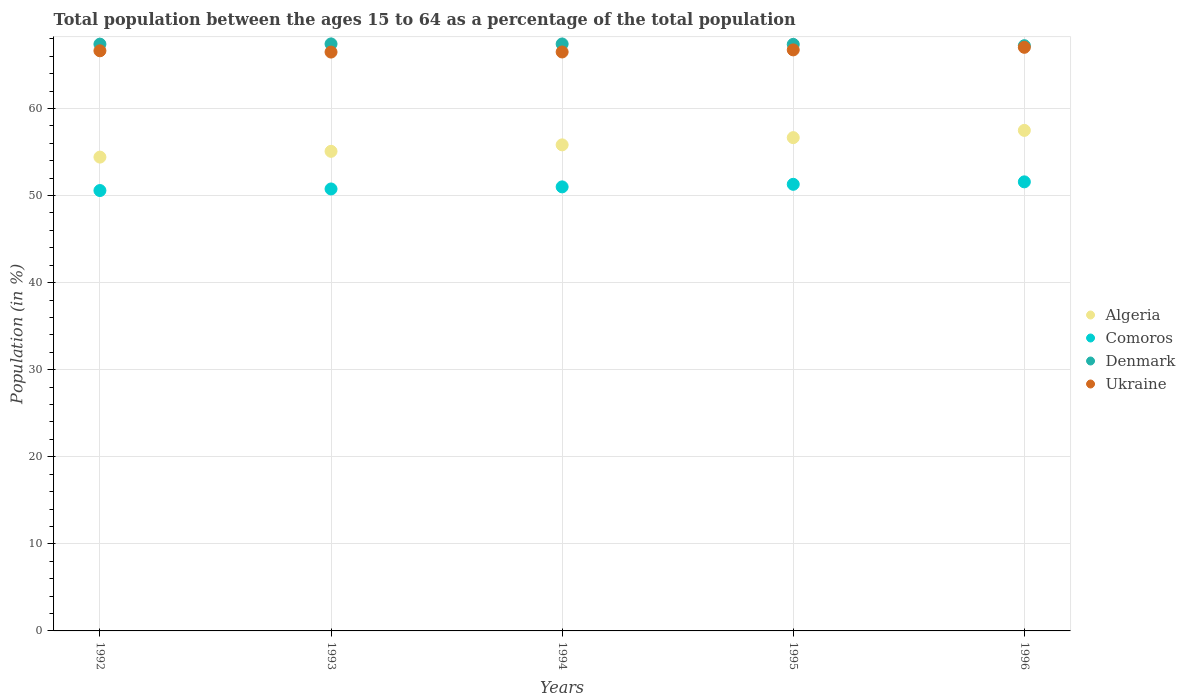How many different coloured dotlines are there?
Keep it short and to the point. 4. What is the percentage of the population ages 15 to 64 in Algeria in 1996?
Provide a succinct answer. 57.48. Across all years, what is the maximum percentage of the population ages 15 to 64 in Denmark?
Make the answer very short. 67.42. Across all years, what is the minimum percentage of the population ages 15 to 64 in Algeria?
Provide a short and direct response. 54.42. In which year was the percentage of the population ages 15 to 64 in Comoros minimum?
Offer a very short reply. 1992. What is the total percentage of the population ages 15 to 64 in Denmark in the graph?
Keep it short and to the point. 336.79. What is the difference between the percentage of the population ages 15 to 64 in Ukraine in 1992 and that in 1996?
Offer a terse response. -0.4. What is the difference between the percentage of the population ages 15 to 64 in Ukraine in 1993 and the percentage of the population ages 15 to 64 in Comoros in 1996?
Offer a terse response. 14.9. What is the average percentage of the population ages 15 to 64 in Denmark per year?
Make the answer very short. 67.36. In the year 1994, what is the difference between the percentage of the population ages 15 to 64 in Denmark and percentage of the population ages 15 to 64 in Ukraine?
Provide a short and direct response. 0.92. In how many years, is the percentage of the population ages 15 to 64 in Denmark greater than 30?
Make the answer very short. 5. What is the ratio of the percentage of the population ages 15 to 64 in Comoros in 1992 to that in 1993?
Keep it short and to the point. 1. Is the percentage of the population ages 15 to 64 in Algeria in 1992 less than that in 1993?
Give a very brief answer. Yes. Is the difference between the percentage of the population ages 15 to 64 in Denmark in 1994 and 1996 greater than the difference between the percentage of the population ages 15 to 64 in Ukraine in 1994 and 1996?
Make the answer very short. Yes. What is the difference between the highest and the second highest percentage of the population ages 15 to 64 in Comoros?
Provide a short and direct response. 0.28. What is the difference between the highest and the lowest percentage of the population ages 15 to 64 in Comoros?
Give a very brief answer. 1. Is the sum of the percentage of the population ages 15 to 64 in Algeria in 1995 and 1996 greater than the maximum percentage of the population ages 15 to 64 in Comoros across all years?
Your answer should be compact. Yes. Is it the case that in every year, the sum of the percentage of the population ages 15 to 64 in Comoros and percentage of the population ages 15 to 64 in Denmark  is greater than the percentage of the population ages 15 to 64 in Ukraine?
Keep it short and to the point. Yes. Is the percentage of the population ages 15 to 64 in Denmark strictly less than the percentage of the population ages 15 to 64 in Ukraine over the years?
Your response must be concise. No. How many dotlines are there?
Your response must be concise. 4. How many years are there in the graph?
Your response must be concise. 5. What is the title of the graph?
Keep it short and to the point. Total population between the ages 15 to 64 as a percentage of the total population. What is the label or title of the Y-axis?
Keep it short and to the point. Population (in %). What is the Population (in %) of Algeria in 1992?
Ensure brevity in your answer.  54.42. What is the Population (in %) of Comoros in 1992?
Keep it short and to the point. 50.58. What is the Population (in %) of Denmark in 1992?
Keep it short and to the point. 67.39. What is the Population (in %) in Ukraine in 1992?
Make the answer very short. 66.63. What is the Population (in %) of Algeria in 1993?
Your answer should be compact. 55.08. What is the Population (in %) in Comoros in 1993?
Your answer should be very brief. 50.76. What is the Population (in %) of Denmark in 1993?
Offer a terse response. 67.42. What is the Population (in %) in Ukraine in 1993?
Give a very brief answer. 66.48. What is the Population (in %) of Algeria in 1994?
Your response must be concise. 55.82. What is the Population (in %) of Comoros in 1994?
Provide a succinct answer. 51. What is the Population (in %) in Denmark in 1994?
Make the answer very short. 67.41. What is the Population (in %) of Ukraine in 1994?
Provide a short and direct response. 66.49. What is the Population (in %) of Algeria in 1995?
Give a very brief answer. 56.65. What is the Population (in %) of Comoros in 1995?
Your response must be concise. 51.29. What is the Population (in %) in Denmark in 1995?
Provide a succinct answer. 67.36. What is the Population (in %) of Ukraine in 1995?
Your response must be concise. 66.73. What is the Population (in %) in Algeria in 1996?
Keep it short and to the point. 57.48. What is the Population (in %) of Comoros in 1996?
Ensure brevity in your answer.  51.57. What is the Population (in %) in Denmark in 1996?
Ensure brevity in your answer.  67.21. What is the Population (in %) in Ukraine in 1996?
Your answer should be very brief. 67.02. Across all years, what is the maximum Population (in %) in Algeria?
Provide a succinct answer. 57.48. Across all years, what is the maximum Population (in %) of Comoros?
Ensure brevity in your answer.  51.57. Across all years, what is the maximum Population (in %) in Denmark?
Offer a terse response. 67.42. Across all years, what is the maximum Population (in %) of Ukraine?
Your answer should be very brief. 67.02. Across all years, what is the minimum Population (in %) in Algeria?
Give a very brief answer. 54.42. Across all years, what is the minimum Population (in %) in Comoros?
Your response must be concise. 50.58. Across all years, what is the minimum Population (in %) in Denmark?
Provide a succinct answer. 67.21. Across all years, what is the minimum Population (in %) of Ukraine?
Your response must be concise. 66.48. What is the total Population (in %) of Algeria in the graph?
Offer a terse response. 279.45. What is the total Population (in %) in Comoros in the graph?
Your response must be concise. 255.19. What is the total Population (in %) in Denmark in the graph?
Offer a terse response. 336.79. What is the total Population (in %) of Ukraine in the graph?
Offer a very short reply. 333.35. What is the difference between the Population (in %) of Algeria in 1992 and that in 1993?
Make the answer very short. -0.66. What is the difference between the Population (in %) in Comoros in 1992 and that in 1993?
Provide a short and direct response. -0.18. What is the difference between the Population (in %) in Denmark in 1992 and that in 1993?
Offer a terse response. -0.03. What is the difference between the Population (in %) in Ukraine in 1992 and that in 1993?
Give a very brief answer. 0.15. What is the difference between the Population (in %) of Algeria in 1992 and that in 1994?
Offer a very short reply. -1.41. What is the difference between the Population (in %) of Comoros in 1992 and that in 1994?
Ensure brevity in your answer.  -0.42. What is the difference between the Population (in %) in Denmark in 1992 and that in 1994?
Your answer should be compact. -0.02. What is the difference between the Population (in %) in Ukraine in 1992 and that in 1994?
Offer a very short reply. 0.14. What is the difference between the Population (in %) of Algeria in 1992 and that in 1995?
Offer a terse response. -2.24. What is the difference between the Population (in %) of Comoros in 1992 and that in 1995?
Your answer should be compact. -0.71. What is the difference between the Population (in %) in Denmark in 1992 and that in 1995?
Keep it short and to the point. 0.03. What is the difference between the Population (in %) of Ukraine in 1992 and that in 1995?
Make the answer very short. -0.1. What is the difference between the Population (in %) in Algeria in 1992 and that in 1996?
Ensure brevity in your answer.  -3.07. What is the difference between the Population (in %) of Comoros in 1992 and that in 1996?
Offer a terse response. -1. What is the difference between the Population (in %) in Denmark in 1992 and that in 1996?
Your answer should be very brief. 0.18. What is the difference between the Population (in %) of Ukraine in 1992 and that in 1996?
Give a very brief answer. -0.4. What is the difference between the Population (in %) in Algeria in 1993 and that in 1994?
Give a very brief answer. -0.74. What is the difference between the Population (in %) of Comoros in 1993 and that in 1994?
Provide a succinct answer. -0.24. What is the difference between the Population (in %) of Denmark in 1993 and that in 1994?
Your answer should be very brief. 0.01. What is the difference between the Population (in %) in Ukraine in 1993 and that in 1994?
Give a very brief answer. -0.01. What is the difference between the Population (in %) of Algeria in 1993 and that in 1995?
Your answer should be very brief. -1.57. What is the difference between the Population (in %) in Comoros in 1993 and that in 1995?
Your answer should be very brief. -0.53. What is the difference between the Population (in %) in Denmark in 1993 and that in 1995?
Provide a succinct answer. 0.05. What is the difference between the Population (in %) of Ukraine in 1993 and that in 1995?
Your answer should be compact. -0.25. What is the difference between the Population (in %) of Algeria in 1993 and that in 1996?
Ensure brevity in your answer.  -2.4. What is the difference between the Population (in %) in Comoros in 1993 and that in 1996?
Your answer should be very brief. -0.82. What is the difference between the Population (in %) of Denmark in 1993 and that in 1996?
Offer a very short reply. 0.2. What is the difference between the Population (in %) of Ukraine in 1993 and that in 1996?
Provide a succinct answer. -0.55. What is the difference between the Population (in %) of Algeria in 1994 and that in 1995?
Your answer should be compact. -0.83. What is the difference between the Population (in %) of Comoros in 1994 and that in 1995?
Make the answer very short. -0.29. What is the difference between the Population (in %) in Denmark in 1994 and that in 1995?
Ensure brevity in your answer.  0.05. What is the difference between the Population (in %) of Ukraine in 1994 and that in 1995?
Your answer should be compact. -0.24. What is the difference between the Population (in %) in Algeria in 1994 and that in 1996?
Provide a short and direct response. -1.66. What is the difference between the Population (in %) of Comoros in 1994 and that in 1996?
Your answer should be very brief. -0.58. What is the difference between the Population (in %) of Denmark in 1994 and that in 1996?
Offer a terse response. 0.2. What is the difference between the Population (in %) in Ukraine in 1994 and that in 1996?
Ensure brevity in your answer.  -0.54. What is the difference between the Population (in %) in Algeria in 1995 and that in 1996?
Your answer should be very brief. -0.83. What is the difference between the Population (in %) in Comoros in 1995 and that in 1996?
Your answer should be compact. -0.28. What is the difference between the Population (in %) in Denmark in 1995 and that in 1996?
Your answer should be compact. 0.15. What is the difference between the Population (in %) of Ukraine in 1995 and that in 1996?
Provide a short and direct response. -0.3. What is the difference between the Population (in %) of Algeria in 1992 and the Population (in %) of Comoros in 1993?
Ensure brevity in your answer.  3.66. What is the difference between the Population (in %) of Algeria in 1992 and the Population (in %) of Denmark in 1993?
Offer a very short reply. -13. What is the difference between the Population (in %) of Algeria in 1992 and the Population (in %) of Ukraine in 1993?
Provide a succinct answer. -12.06. What is the difference between the Population (in %) of Comoros in 1992 and the Population (in %) of Denmark in 1993?
Ensure brevity in your answer.  -16.84. What is the difference between the Population (in %) of Comoros in 1992 and the Population (in %) of Ukraine in 1993?
Keep it short and to the point. -15.9. What is the difference between the Population (in %) in Denmark in 1992 and the Population (in %) in Ukraine in 1993?
Your answer should be compact. 0.91. What is the difference between the Population (in %) in Algeria in 1992 and the Population (in %) in Comoros in 1994?
Ensure brevity in your answer.  3.42. What is the difference between the Population (in %) in Algeria in 1992 and the Population (in %) in Denmark in 1994?
Keep it short and to the point. -12.99. What is the difference between the Population (in %) in Algeria in 1992 and the Population (in %) in Ukraine in 1994?
Give a very brief answer. -12.07. What is the difference between the Population (in %) in Comoros in 1992 and the Population (in %) in Denmark in 1994?
Give a very brief answer. -16.83. What is the difference between the Population (in %) of Comoros in 1992 and the Population (in %) of Ukraine in 1994?
Your answer should be compact. -15.91. What is the difference between the Population (in %) in Denmark in 1992 and the Population (in %) in Ukraine in 1994?
Provide a short and direct response. 0.9. What is the difference between the Population (in %) of Algeria in 1992 and the Population (in %) of Comoros in 1995?
Offer a very short reply. 3.12. What is the difference between the Population (in %) of Algeria in 1992 and the Population (in %) of Denmark in 1995?
Your answer should be very brief. -12.95. What is the difference between the Population (in %) in Algeria in 1992 and the Population (in %) in Ukraine in 1995?
Give a very brief answer. -12.31. What is the difference between the Population (in %) in Comoros in 1992 and the Population (in %) in Denmark in 1995?
Give a very brief answer. -16.79. What is the difference between the Population (in %) in Comoros in 1992 and the Population (in %) in Ukraine in 1995?
Keep it short and to the point. -16.15. What is the difference between the Population (in %) of Denmark in 1992 and the Population (in %) of Ukraine in 1995?
Ensure brevity in your answer.  0.66. What is the difference between the Population (in %) of Algeria in 1992 and the Population (in %) of Comoros in 1996?
Provide a short and direct response. 2.84. What is the difference between the Population (in %) in Algeria in 1992 and the Population (in %) in Denmark in 1996?
Offer a very short reply. -12.8. What is the difference between the Population (in %) of Algeria in 1992 and the Population (in %) of Ukraine in 1996?
Provide a succinct answer. -12.61. What is the difference between the Population (in %) in Comoros in 1992 and the Population (in %) in Denmark in 1996?
Offer a terse response. -16.64. What is the difference between the Population (in %) of Comoros in 1992 and the Population (in %) of Ukraine in 1996?
Give a very brief answer. -16.45. What is the difference between the Population (in %) in Denmark in 1992 and the Population (in %) in Ukraine in 1996?
Offer a very short reply. 0.36. What is the difference between the Population (in %) of Algeria in 1993 and the Population (in %) of Comoros in 1994?
Make the answer very short. 4.08. What is the difference between the Population (in %) in Algeria in 1993 and the Population (in %) in Denmark in 1994?
Offer a terse response. -12.33. What is the difference between the Population (in %) in Algeria in 1993 and the Population (in %) in Ukraine in 1994?
Your response must be concise. -11.41. What is the difference between the Population (in %) of Comoros in 1993 and the Population (in %) of Denmark in 1994?
Offer a terse response. -16.65. What is the difference between the Population (in %) in Comoros in 1993 and the Population (in %) in Ukraine in 1994?
Provide a short and direct response. -15.73. What is the difference between the Population (in %) in Denmark in 1993 and the Population (in %) in Ukraine in 1994?
Offer a very short reply. 0.93. What is the difference between the Population (in %) of Algeria in 1993 and the Population (in %) of Comoros in 1995?
Your answer should be compact. 3.79. What is the difference between the Population (in %) of Algeria in 1993 and the Population (in %) of Denmark in 1995?
Offer a very short reply. -12.28. What is the difference between the Population (in %) of Algeria in 1993 and the Population (in %) of Ukraine in 1995?
Keep it short and to the point. -11.65. What is the difference between the Population (in %) of Comoros in 1993 and the Population (in %) of Denmark in 1995?
Give a very brief answer. -16.6. What is the difference between the Population (in %) of Comoros in 1993 and the Population (in %) of Ukraine in 1995?
Ensure brevity in your answer.  -15.97. What is the difference between the Population (in %) of Denmark in 1993 and the Population (in %) of Ukraine in 1995?
Ensure brevity in your answer.  0.69. What is the difference between the Population (in %) of Algeria in 1993 and the Population (in %) of Comoros in 1996?
Provide a succinct answer. 3.51. What is the difference between the Population (in %) of Algeria in 1993 and the Population (in %) of Denmark in 1996?
Your answer should be very brief. -12.13. What is the difference between the Population (in %) in Algeria in 1993 and the Population (in %) in Ukraine in 1996?
Ensure brevity in your answer.  -11.95. What is the difference between the Population (in %) of Comoros in 1993 and the Population (in %) of Denmark in 1996?
Keep it short and to the point. -16.45. What is the difference between the Population (in %) in Comoros in 1993 and the Population (in %) in Ukraine in 1996?
Offer a very short reply. -16.27. What is the difference between the Population (in %) of Denmark in 1993 and the Population (in %) of Ukraine in 1996?
Give a very brief answer. 0.39. What is the difference between the Population (in %) in Algeria in 1994 and the Population (in %) in Comoros in 1995?
Make the answer very short. 4.53. What is the difference between the Population (in %) in Algeria in 1994 and the Population (in %) in Denmark in 1995?
Offer a very short reply. -11.54. What is the difference between the Population (in %) of Algeria in 1994 and the Population (in %) of Ukraine in 1995?
Offer a very short reply. -10.91. What is the difference between the Population (in %) of Comoros in 1994 and the Population (in %) of Denmark in 1995?
Offer a terse response. -16.37. What is the difference between the Population (in %) in Comoros in 1994 and the Population (in %) in Ukraine in 1995?
Provide a succinct answer. -15.73. What is the difference between the Population (in %) in Denmark in 1994 and the Population (in %) in Ukraine in 1995?
Keep it short and to the point. 0.68. What is the difference between the Population (in %) in Algeria in 1994 and the Population (in %) in Comoros in 1996?
Provide a short and direct response. 4.25. What is the difference between the Population (in %) of Algeria in 1994 and the Population (in %) of Denmark in 1996?
Provide a short and direct response. -11.39. What is the difference between the Population (in %) in Algeria in 1994 and the Population (in %) in Ukraine in 1996?
Provide a succinct answer. -11.2. What is the difference between the Population (in %) of Comoros in 1994 and the Population (in %) of Denmark in 1996?
Ensure brevity in your answer.  -16.22. What is the difference between the Population (in %) in Comoros in 1994 and the Population (in %) in Ukraine in 1996?
Your response must be concise. -16.03. What is the difference between the Population (in %) of Denmark in 1994 and the Population (in %) of Ukraine in 1996?
Offer a very short reply. 0.38. What is the difference between the Population (in %) in Algeria in 1995 and the Population (in %) in Comoros in 1996?
Ensure brevity in your answer.  5.08. What is the difference between the Population (in %) of Algeria in 1995 and the Population (in %) of Denmark in 1996?
Provide a short and direct response. -10.56. What is the difference between the Population (in %) of Algeria in 1995 and the Population (in %) of Ukraine in 1996?
Make the answer very short. -10.37. What is the difference between the Population (in %) of Comoros in 1995 and the Population (in %) of Denmark in 1996?
Make the answer very short. -15.92. What is the difference between the Population (in %) in Comoros in 1995 and the Population (in %) in Ukraine in 1996?
Ensure brevity in your answer.  -15.73. What is the difference between the Population (in %) of Denmark in 1995 and the Population (in %) of Ukraine in 1996?
Offer a very short reply. 0.34. What is the average Population (in %) in Algeria per year?
Offer a very short reply. 55.89. What is the average Population (in %) of Comoros per year?
Your response must be concise. 51.04. What is the average Population (in %) in Denmark per year?
Give a very brief answer. 67.36. What is the average Population (in %) of Ukraine per year?
Provide a succinct answer. 66.67. In the year 1992, what is the difference between the Population (in %) of Algeria and Population (in %) of Comoros?
Offer a terse response. 3.84. In the year 1992, what is the difference between the Population (in %) of Algeria and Population (in %) of Denmark?
Make the answer very short. -12.97. In the year 1992, what is the difference between the Population (in %) of Algeria and Population (in %) of Ukraine?
Your response must be concise. -12.21. In the year 1992, what is the difference between the Population (in %) of Comoros and Population (in %) of Denmark?
Your response must be concise. -16.81. In the year 1992, what is the difference between the Population (in %) of Comoros and Population (in %) of Ukraine?
Make the answer very short. -16.05. In the year 1992, what is the difference between the Population (in %) of Denmark and Population (in %) of Ukraine?
Provide a succinct answer. 0.76. In the year 1993, what is the difference between the Population (in %) of Algeria and Population (in %) of Comoros?
Provide a succinct answer. 4.32. In the year 1993, what is the difference between the Population (in %) of Algeria and Population (in %) of Denmark?
Give a very brief answer. -12.34. In the year 1993, what is the difference between the Population (in %) of Algeria and Population (in %) of Ukraine?
Your answer should be compact. -11.4. In the year 1993, what is the difference between the Population (in %) in Comoros and Population (in %) in Denmark?
Your response must be concise. -16.66. In the year 1993, what is the difference between the Population (in %) in Comoros and Population (in %) in Ukraine?
Make the answer very short. -15.72. In the year 1993, what is the difference between the Population (in %) of Denmark and Population (in %) of Ukraine?
Your answer should be compact. 0.94. In the year 1994, what is the difference between the Population (in %) of Algeria and Population (in %) of Comoros?
Ensure brevity in your answer.  4.83. In the year 1994, what is the difference between the Population (in %) in Algeria and Population (in %) in Denmark?
Offer a very short reply. -11.59. In the year 1994, what is the difference between the Population (in %) in Algeria and Population (in %) in Ukraine?
Your answer should be very brief. -10.67. In the year 1994, what is the difference between the Population (in %) of Comoros and Population (in %) of Denmark?
Give a very brief answer. -16.41. In the year 1994, what is the difference between the Population (in %) of Comoros and Population (in %) of Ukraine?
Ensure brevity in your answer.  -15.49. In the year 1994, what is the difference between the Population (in %) in Denmark and Population (in %) in Ukraine?
Give a very brief answer. 0.92. In the year 1995, what is the difference between the Population (in %) of Algeria and Population (in %) of Comoros?
Your answer should be compact. 5.36. In the year 1995, what is the difference between the Population (in %) of Algeria and Population (in %) of Denmark?
Provide a short and direct response. -10.71. In the year 1995, what is the difference between the Population (in %) in Algeria and Population (in %) in Ukraine?
Offer a terse response. -10.08. In the year 1995, what is the difference between the Population (in %) of Comoros and Population (in %) of Denmark?
Keep it short and to the point. -16.07. In the year 1995, what is the difference between the Population (in %) of Comoros and Population (in %) of Ukraine?
Give a very brief answer. -15.44. In the year 1995, what is the difference between the Population (in %) in Denmark and Population (in %) in Ukraine?
Give a very brief answer. 0.63. In the year 1996, what is the difference between the Population (in %) of Algeria and Population (in %) of Comoros?
Your answer should be compact. 5.91. In the year 1996, what is the difference between the Population (in %) of Algeria and Population (in %) of Denmark?
Make the answer very short. -9.73. In the year 1996, what is the difference between the Population (in %) of Algeria and Population (in %) of Ukraine?
Your answer should be very brief. -9.54. In the year 1996, what is the difference between the Population (in %) in Comoros and Population (in %) in Denmark?
Your answer should be compact. -15.64. In the year 1996, what is the difference between the Population (in %) in Comoros and Population (in %) in Ukraine?
Keep it short and to the point. -15.45. In the year 1996, what is the difference between the Population (in %) in Denmark and Population (in %) in Ukraine?
Keep it short and to the point. 0.19. What is the ratio of the Population (in %) of Algeria in 1992 to that in 1993?
Keep it short and to the point. 0.99. What is the ratio of the Population (in %) of Ukraine in 1992 to that in 1993?
Provide a short and direct response. 1. What is the ratio of the Population (in %) in Algeria in 1992 to that in 1994?
Provide a short and direct response. 0.97. What is the ratio of the Population (in %) in Comoros in 1992 to that in 1994?
Offer a terse response. 0.99. What is the ratio of the Population (in %) of Denmark in 1992 to that in 1994?
Offer a very short reply. 1. What is the ratio of the Population (in %) in Ukraine in 1992 to that in 1994?
Your response must be concise. 1. What is the ratio of the Population (in %) in Algeria in 1992 to that in 1995?
Offer a terse response. 0.96. What is the ratio of the Population (in %) in Comoros in 1992 to that in 1995?
Provide a short and direct response. 0.99. What is the ratio of the Population (in %) in Denmark in 1992 to that in 1995?
Provide a short and direct response. 1. What is the ratio of the Population (in %) in Ukraine in 1992 to that in 1995?
Make the answer very short. 1. What is the ratio of the Population (in %) of Algeria in 1992 to that in 1996?
Your answer should be compact. 0.95. What is the ratio of the Population (in %) of Comoros in 1992 to that in 1996?
Your response must be concise. 0.98. What is the ratio of the Population (in %) of Denmark in 1992 to that in 1996?
Give a very brief answer. 1. What is the ratio of the Population (in %) of Algeria in 1993 to that in 1994?
Your response must be concise. 0.99. What is the ratio of the Population (in %) of Comoros in 1993 to that in 1994?
Give a very brief answer. 1. What is the ratio of the Population (in %) of Ukraine in 1993 to that in 1994?
Provide a succinct answer. 1. What is the ratio of the Population (in %) of Algeria in 1993 to that in 1995?
Offer a terse response. 0.97. What is the ratio of the Population (in %) in Ukraine in 1993 to that in 1995?
Make the answer very short. 1. What is the ratio of the Population (in %) in Algeria in 1993 to that in 1996?
Ensure brevity in your answer.  0.96. What is the ratio of the Population (in %) in Comoros in 1993 to that in 1996?
Offer a very short reply. 0.98. What is the ratio of the Population (in %) in Algeria in 1994 to that in 1995?
Ensure brevity in your answer.  0.99. What is the ratio of the Population (in %) in Denmark in 1994 to that in 1995?
Make the answer very short. 1. What is the ratio of the Population (in %) in Ukraine in 1994 to that in 1995?
Provide a short and direct response. 1. What is the ratio of the Population (in %) of Algeria in 1994 to that in 1996?
Your answer should be very brief. 0.97. What is the ratio of the Population (in %) in Comoros in 1994 to that in 1996?
Give a very brief answer. 0.99. What is the ratio of the Population (in %) in Ukraine in 1994 to that in 1996?
Your response must be concise. 0.99. What is the ratio of the Population (in %) of Algeria in 1995 to that in 1996?
Give a very brief answer. 0.99. What is the ratio of the Population (in %) in Ukraine in 1995 to that in 1996?
Provide a succinct answer. 1. What is the difference between the highest and the second highest Population (in %) in Algeria?
Make the answer very short. 0.83. What is the difference between the highest and the second highest Population (in %) in Comoros?
Give a very brief answer. 0.28. What is the difference between the highest and the second highest Population (in %) of Denmark?
Keep it short and to the point. 0.01. What is the difference between the highest and the second highest Population (in %) in Ukraine?
Provide a short and direct response. 0.3. What is the difference between the highest and the lowest Population (in %) of Algeria?
Offer a terse response. 3.07. What is the difference between the highest and the lowest Population (in %) of Denmark?
Your response must be concise. 0.2. What is the difference between the highest and the lowest Population (in %) of Ukraine?
Keep it short and to the point. 0.55. 